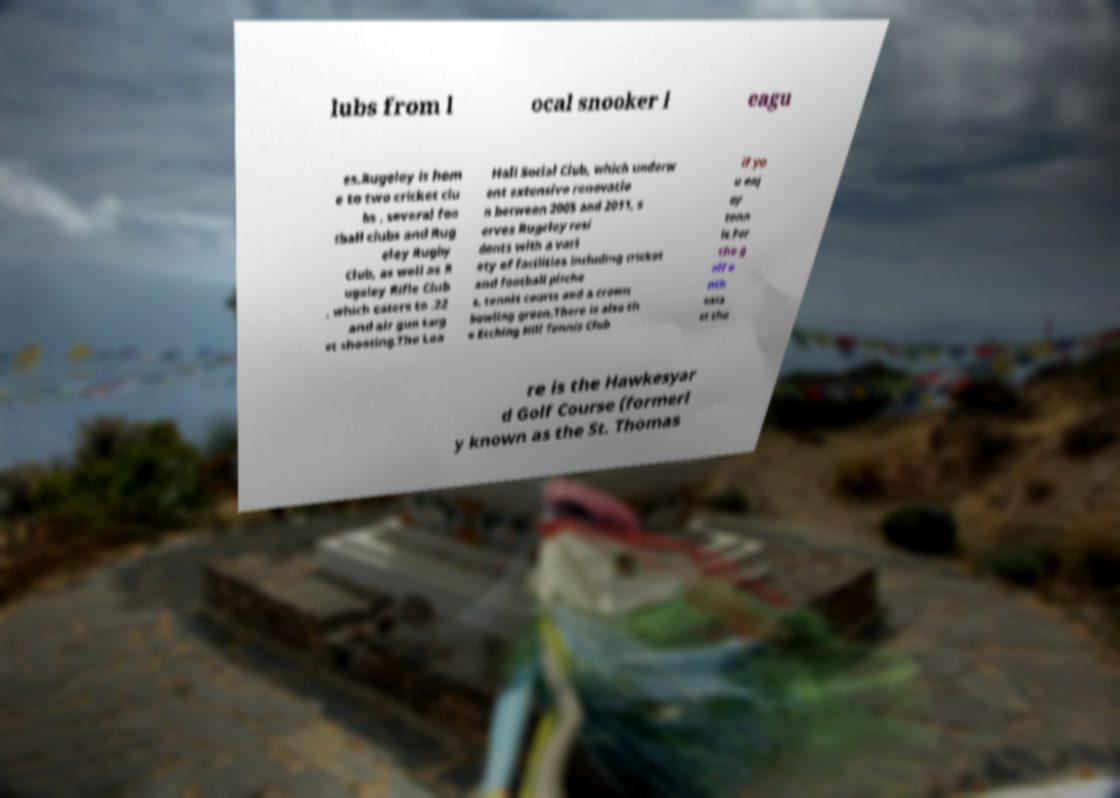Can you read and provide the text displayed in the image?This photo seems to have some interesting text. Can you extract and type it out for me? lubs from l ocal snooker l eagu es.Rugeley is hom e to two cricket clu bs , several foo tball clubs and Rug eley Rugby Club, as well as R ugeley Rifle Club , which caters to .22 and air gun targ et shooting.The Lea Hall Social Club, which underw ent extensive renovatio n between 2005 and 2011, s erves Rugeley resi dents with a vari ety of facilities including cricket and football pitche s, tennis courts and a crown bowling green.There is also th e Etching Hill Tennis Club if yo u enj oy tenn is.For the g olf e nth usia st the re is the Hawkesyar d Golf Course (formerl y known as the St. Thomas 